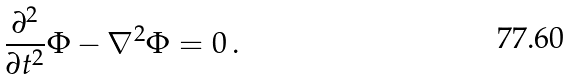<formula> <loc_0><loc_0><loc_500><loc_500>\frac { \partial ^ { 2 } } { \partial t ^ { 2 } } \Phi - \nabla ^ { 2 } \Phi = 0 \, .</formula> 